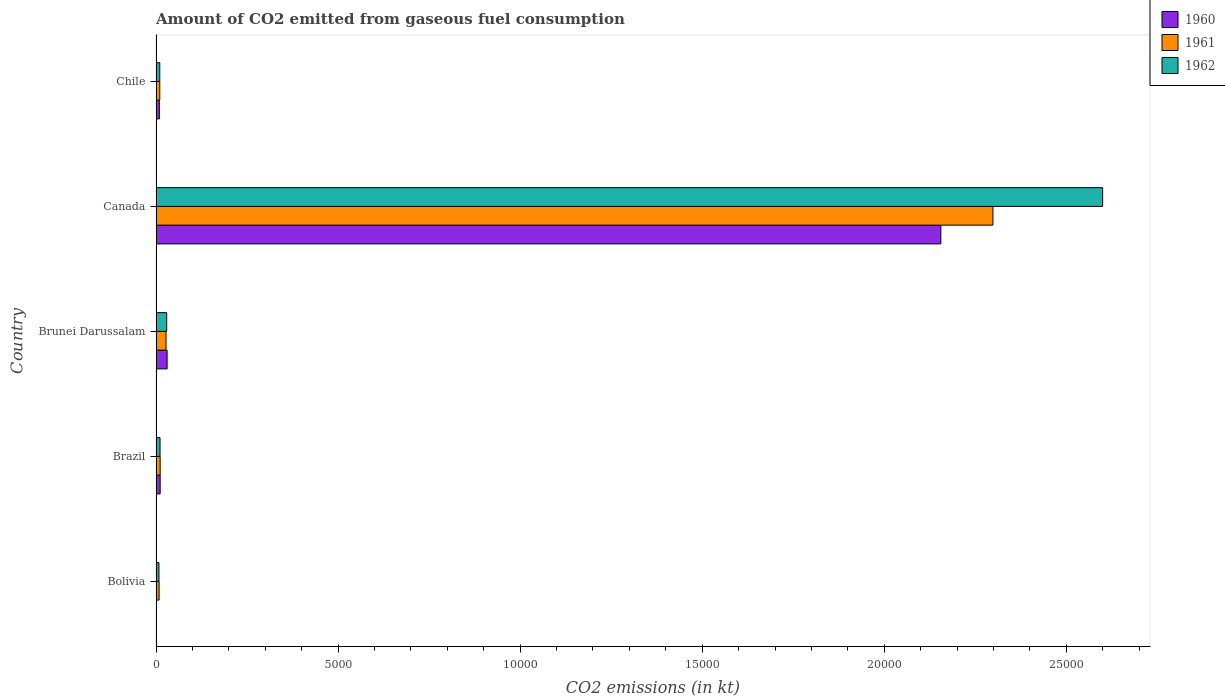Are the number of bars per tick equal to the number of legend labels?
Provide a short and direct response. Yes. Are the number of bars on each tick of the Y-axis equal?
Offer a very short reply. Yes. How many bars are there on the 2nd tick from the bottom?
Offer a terse response. 3. What is the label of the 1st group of bars from the top?
Your response must be concise. Chile. In how many cases, is the number of bars for a given country not equal to the number of legend labels?
Offer a terse response. 0. What is the amount of CO2 emitted in 1960 in Brazil?
Give a very brief answer. 113.68. Across all countries, what is the maximum amount of CO2 emitted in 1961?
Your response must be concise. 2.30e+04. Across all countries, what is the minimum amount of CO2 emitted in 1960?
Keep it short and to the point. 11. In which country was the amount of CO2 emitted in 1962 maximum?
Ensure brevity in your answer.  Canada. What is the total amount of CO2 emitted in 1961 in the graph?
Offer a terse response. 2.36e+04. What is the difference between the amount of CO2 emitted in 1962 in Bolivia and that in Chile?
Your answer should be compact. -22. What is the difference between the amount of CO2 emitted in 1960 in Canada and the amount of CO2 emitted in 1961 in Brazil?
Provide a succinct answer. 2.14e+04. What is the average amount of CO2 emitted in 1960 per country?
Your response must be concise. 4415.07. What is the difference between the amount of CO2 emitted in 1960 and amount of CO2 emitted in 1962 in Canada?
Give a very brief answer. -4444.4. What is the ratio of the amount of CO2 emitted in 1961 in Brunei Darussalam to that in Canada?
Your response must be concise. 0.01. Is the amount of CO2 emitted in 1962 in Brunei Darussalam less than that in Canada?
Provide a succinct answer. Yes. Is the difference between the amount of CO2 emitted in 1960 in Bolivia and Brunei Darussalam greater than the difference between the amount of CO2 emitted in 1962 in Bolivia and Brunei Darussalam?
Provide a short and direct response. No. What is the difference between the highest and the second highest amount of CO2 emitted in 1962?
Your response must be concise. 2.57e+04. What is the difference between the highest and the lowest amount of CO2 emitted in 1960?
Make the answer very short. 2.15e+04. What does the 3rd bar from the bottom in Brunei Darussalam represents?
Provide a short and direct response. 1962. Are all the bars in the graph horizontal?
Offer a terse response. Yes. How many countries are there in the graph?
Make the answer very short. 5. Where does the legend appear in the graph?
Your answer should be very brief. Top right. How many legend labels are there?
Your answer should be very brief. 3. How are the legend labels stacked?
Provide a short and direct response. Vertical. What is the title of the graph?
Your response must be concise. Amount of CO2 emitted from gaseous fuel consumption. What is the label or title of the X-axis?
Make the answer very short. CO2 emissions (in kt). What is the CO2 emissions (in kt) in 1960 in Bolivia?
Offer a very short reply. 11. What is the CO2 emissions (in kt) of 1961 in Bolivia?
Your response must be concise. 84.34. What is the CO2 emissions (in kt) of 1962 in Bolivia?
Ensure brevity in your answer.  80.67. What is the CO2 emissions (in kt) of 1960 in Brazil?
Your answer should be compact. 113.68. What is the CO2 emissions (in kt) of 1961 in Brazil?
Your response must be concise. 113.68. What is the CO2 emissions (in kt) of 1962 in Brazil?
Ensure brevity in your answer.  110.01. What is the CO2 emissions (in kt) in 1960 in Brunei Darussalam?
Offer a very short reply. 304.36. What is the CO2 emissions (in kt) of 1961 in Brunei Darussalam?
Provide a succinct answer. 275.02. What is the CO2 emissions (in kt) in 1962 in Brunei Darussalam?
Provide a short and direct response. 293.36. What is the CO2 emissions (in kt) in 1960 in Canada?
Your answer should be compact. 2.16e+04. What is the CO2 emissions (in kt) in 1961 in Canada?
Provide a succinct answer. 2.30e+04. What is the CO2 emissions (in kt) of 1962 in Canada?
Give a very brief answer. 2.60e+04. What is the CO2 emissions (in kt) in 1960 in Chile?
Your answer should be compact. 91.67. What is the CO2 emissions (in kt) in 1961 in Chile?
Give a very brief answer. 102.68. What is the CO2 emissions (in kt) of 1962 in Chile?
Make the answer very short. 102.68. Across all countries, what is the maximum CO2 emissions (in kt) in 1960?
Give a very brief answer. 2.16e+04. Across all countries, what is the maximum CO2 emissions (in kt) in 1961?
Offer a very short reply. 2.30e+04. Across all countries, what is the maximum CO2 emissions (in kt) in 1962?
Keep it short and to the point. 2.60e+04. Across all countries, what is the minimum CO2 emissions (in kt) in 1960?
Offer a very short reply. 11. Across all countries, what is the minimum CO2 emissions (in kt) in 1961?
Give a very brief answer. 84.34. Across all countries, what is the minimum CO2 emissions (in kt) of 1962?
Make the answer very short. 80.67. What is the total CO2 emissions (in kt) in 1960 in the graph?
Your answer should be compact. 2.21e+04. What is the total CO2 emissions (in kt) in 1961 in the graph?
Give a very brief answer. 2.36e+04. What is the total CO2 emissions (in kt) of 1962 in the graph?
Provide a short and direct response. 2.66e+04. What is the difference between the CO2 emissions (in kt) in 1960 in Bolivia and that in Brazil?
Keep it short and to the point. -102.68. What is the difference between the CO2 emissions (in kt) in 1961 in Bolivia and that in Brazil?
Ensure brevity in your answer.  -29.34. What is the difference between the CO2 emissions (in kt) in 1962 in Bolivia and that in Brazil?
Ensure brevity in your answer.  -29.34. What is the difference between the CO2 emissions (in kt) of 1960 in Bolivia and that in Brunei Darussalam?
Make the answer very short. -293.36. What is the difference between the CO2 emissions (in kt) of 1961 in Bolivia and that in Brunei Darussalam?
Make the answer very short. -190.68. What is the difference between the CO2 emissions (in kt) in 1962 in Bolivia and that in Brunei Darussalam?
Provide a short and direct response. -212.69. What is the difference between the CO2 emissions (in kt) of 1960 in Bolivia and that in Canada?
Offer a terse response. -2.15e+04. What is the difference between the CO2 emissions (in kt) of 1961 in Bolivia and that in Canada?
Make the answer very short. -2.29e+04. What is the difference between the CO2 emissions (in kt) in 1962 in Bolivia and that in Canada?
Your answer should be compact. -2.59e+04. What is the difference between the CO2 emissions (in kt) in 1960 in Bolivia and that in Chile?
Your response must be concise. -80.67. What is the difference between the CO2 emissions (in kt) in 1961 in Bolivia and that in Chile?
Keep it short and to the point. -18.34. What is the difference between the CO2 emissions (in kt) of 1962 in Bolivia and that in Chile?
Your answer should be compact. -22. What is the difference between the CO2 emissions (in kt) in 1960 in Brazil and that in Brunei Darussalam?
Provide a short and direct response. -190.68. What is the difference between the CO2 emissions (in kt) in 1961 in Brazil and that in Brunei Darussalam?
Offer a very short reply. -161.35. What is the difference between the CO2 emissions (in kt) of 1962 in Brazil and that in Brunei Darussalam?
Offer a terse response. -183.35. What is the difference between the CO2 emissions (in kt) in 1960 in Brazil and that in Canada?
Provide a short and direct response. -2.14e+04. What is the difference between the CO2 emissions (in kt) of 1961 in Brazil and that in Canada?
Keep it short and to the point. -2.29e+04. What is the difference between the CO2 emissions (in kt) of 1962 in Brazil and that in Canada?
Give a very brief answer. -2.59e+04. What is the difference between the CO2 emissions (in kt) of 1960 in Brazil and that in Chile?
Provide a short and direct response. 22. What is the difference between the CO2 emissions (in kt) of 1961 in Brazil and that in Chile?
Make the answer very short. 11. What is the difference between the CO2 emissions (in kt) of 1962 in Brazil and that in Chile?
Ensure brevity in your answer.  7.33. What is the difference between the CO2 emissions (in kt) in 1960 in Brunei Darussalam and that in Canada?
Offer a very short reply. -2.13e+04. What is the difference between the CO2 emissions (in kt) in 1961 in Brunei Darussalam and that in Canada?
Provide a succinct answer. -2.27e+04. What is the difference between the CO2 emissions (in kt) in 1962 in Brunei Darussalam and that in Canada?
Provide a succinct answer. -2.57e+04. What is the difference between the CO2 emissions (in kt) in 1960 in Brunei Darussalam and that in Chile?
Keep it short and to the point. 212.69. What is the difference between the CO2 emissions (in kt) in 1961 in Brunei Darussalam and that in Chile?
Make the answer very short. 172.35. What is the difference between the CO2 emissions (in kt) of 1962 in Brunei Darussalam and that in Chile?
Provide a short and direct response. 190.68. What is the difference between the CO2 emissions (in kt) of 1960 in Canada and that in Chile?
Your answer should be very brief. 2.15e+04. What is the difference between the CO2 emissions (in kt) in 1961 in Canada and that in Chile?
Give a very brief answer. 2.29e+04. What is the difference between the CO2 emissions (in kt) in 1962 in Canada and that in Chile?
Provide a succinct answer. 2.59e+04. What is the difference between the CO2 emissions (in kt) in 1960 in Bolivia and the CO2 emissions (in kt) in 1961 in Brazil?
Your response must be concise. -102.68. What is the difference between the CO2 emissions (in kt) of 1960 in Bolivia and the CO2 emissions (in kt) of 1962 in Brazil?
Your answer should be very brief. -99.01. What is the difference between the CO2 emissions (in kt) of 1961 in Bolivia and the CO2 emissions (in kt) of 1962 in Brazil?
Your answer should be very brief. -25.67. What is the difference between the CO2 emissions (in kt) in 1960 in Bolivia and the CO2 emissions (in kt) in 1961 in Brunei Darussalam?
Provide a short and direct response. -264.02. What is the difference between the CO2 emissions (in kt) of 1960 in Bolivia and the CO2 emissions (in kt) of 1962 in Brunei Darussalam?
Your answer should be very brief. -282.36. What is the difference between the CO2 emissions (in kt) of 1961 in Bolivia and the CO2 emissions (in kt) of 1962 in Brunei Darussalam?
Offer a terse response. -209.02. What is the difference between the CO2 emissions (in kt) in 1960 in Bolivia and the CO2 emissions (in kt) in 1961 in Canada?
Your answer should be very brief. -2.30e+04. What is the difference between the CO2 emissions (in kt) of 1960 in Bolivia and the CO2 emissions (in kt) of 1962 in Canada?
Keep it short and to the point. -2.60e+04. What is the difference between the CO2 emissions (in kt) of 1961 in Bolivia and the CO2 emissions (in kt) of 1962 in Canada?
Ensure brevity in your answer.  -2.59e+04. What is the difference between the CO2 emissions (in kt) of 1960 in Bolivia and the CO2 emissions (in kt) of 1961 in Chile?
Make the answer very short. -91.67. What is the difference between the CO2 emissions (in kt) in 1960 in Bolivia and the CO2 emissions (in kt) in 1962 in Chile?
Offer a very short reply. -91.67. What is the difference between the CO2 emissions (in kt) of 1961 in Bolivia and the CO2 emissions (in kt) of 1962 in Chile?
Ensure brevity in your answer.  -18.34. What is the difference between the CO2 emissions (in kt) in 1960 in Brazil and the CO2 emissions (in kt) in 1961 in Brunei Darussalam?
Make the answer very short. -161.35. What is the difference between the CO2 emissions (in kt) of 1960 in Brazil and the CO2 emissions (in kt) of 1962 in Brunei Darussalam?
Make the answer very short. -179.68. What is the difference between the CO2 emissions (in kt) in 1961 in Brazil and the CO2 emissions (in kt) in 1962 in Brunei Darussalam?
Offer a very short reply. -179.68. What is the difference between the CO2 emissions (in kt) of 1960 in Brazil and the CO2 emissions (in kt) of 1961 in Canada?
Keep it short and to the point. -2.29e+04. What is the difference between the CO2 emissions (in kt) of 1960 in Brazil and the CO2 emissions (in kt) of 1962 in Canada?
Keep it short and to the point. -2.59e+04. What is the difference between the CO2 emissions (in kt) of 1961 in Brazil and the CO2 emissions (in kt) of 1962 in Canada?
Make the answer very short. -2.59e+04. What is the difference between the CO2 emissions (in kt) in 1960 in Brazil and the CO2 emissions (in kt) in 1961 in Chile?
Offer a very short reply. 11. What is the difference between the CO2 emissions (in kt) in 1960 in Brazil and the CO2 emissions (in kt) in 1962 in Chile?
Provide a succinct answer. 11. What is the difference between the CO2 emissions (in kt) in 1961 in Brazil and the CO2 emissions (in kt) in 1962 in Chile?
Ensure brevity in your answer.  11. What is the difference between the CO2 emissions (in kt) in 1960 in Brunei Darussalam and the CO2 emissions (in kt) in 1961 in Canada?
Offer a terse response. -2.27e+04. What is the difference between the CO2 emissions (in kt) in 1960 in Brunei Darussalam and the CO2 emissions (in kt) in 1962 in Canada?
Provide a short and direct response. -2.57e+04. What is the difference between the CO2 emissions (in kt) in 1961 in Brunei Darussalam and the CO2 emissions (in kt) in 1962 in Canada?
Make the answer very short. -2.57e+04. What is the difference between the CO2 emissions (in kt) in 1960 in Brunei Darussalam and the CO2 emissions (in kt) in 1961 in Chile?
Your answer should be compact. 201.69. What is the difference between the CO2 emissions (in kt) of 1960 in Brunei Darussalam and the CO2 emissions (in kt) of 1962 in Chile?
Offer a terse response. 201.69. What is the difference between the CO2 emissions (in kt) in 1961 in Brunei Darussalam and the CO2 emissions (in kt) in 1962 in Chile?
Provide a short and direct response. 172.35. What is the difference between the CO2 emissions (in kt) of 1960 in Canada and the CO2 emissions (in kt) of 1961 in Chile?
Give a very brief answer. 2.15e+04. What is the difference between the CO2 emissions (in kt) of 1960 in Canada and the CO2 emissions (in kt) of 1962 in Chile?
Your response must be concise. 2.15e+04. What is the difference between the CO2 emissions (in kt) of 1961 in Canada and the CO2 emissions (in kt) of 1962 in Chile?
Provide a succinct answer. 2.29e+04. What is the average CO2 emissions (in kt) of 1960 per country?
Provide a short and direct response. 4415.07. What is the average CO2 emissions (in kt) of 1961 per country?
Provide a succinct answer. 4712.1. What is the average CO2 emissions (in kt) in 1962 per country?
Give a very brief answer. 5317.15. What is the difference between the CO2 emissions (in kt) in 1960 and CO2 emissions (in kt) in 1961 in Bolivia?
Make the answer very short. -73.34. What is the difference between the CO2 emissions (in kt) of 1960 and CO2 emissions (in kt) of 1962 in Bolivia?
Give a very brief answer. -69.67. What is the difference between the CO2 emissions (in kt) in 1961 and CO2 emissions (in kt) in 1962 in Bolivia?
Make the answer very short. 3.67. What is the difference between the CO2 emissions (in kt) of 1960 and CO2 emissions (in kt) of 1962 in Brazil?
Provide a succinct answer. 3.67. What is the difference between the CO2 emissions (in kt) of 1961 and CO2 emissions (in kt) of 1962 in Brazil?
Provide a short and direct response. 3.67. What is the difference between the CO2 emissions (in kt) of 1960 and CO2 emissions (in kt) of 1961 in Brunei Darussalam?
Keep it short and to the point. 29.34. What is the difference between the CO2 emissions (in kt) of 1960 and CO2 emissions (in kt) of 1962 in Brunei Darussalam?
Keep it short and to the point. 11. What is the difference between the CO2 emissions (in kt) of 1961 and CO2 emissions (in kt) of 1962 in Brunei Darussalam?
Make the answer very short. -18.34. What is the difference between the CO2 emissions (in kt) in 1960 and CO2 emissions (in kt) in 1961 in Canada?
Provide a short and direct response. -1430.13. What is the difference between the CO2 emissions (in kt) of 1960 and CO2 emissions (in kt) of 1962 in Canada?
Your answer should be compact. -4444.4. What is the difference between the CO2 emissions (in kt) in 1961 and CO2 emissions (in kt) in 1962 in Canada?
Offer a terse response. -3014.27. What is the difference between the CO2 emissions (in kt) of 1960 and CO2 emissions (in kt) of 1961 in Chile?
Make the answer very short. -11. What is the difference between the CO2 emissions (in kt) in 1960 and CO2 emissions (in kt) in 1962 in Chile?
Give a very brief answer. -11. What is the difference between the CO2 emissions (in kt) in 1961 and CO2 emissions (in kt) in 1962 in Chile?
Give a very brief answer. 0. What is the ratio of the CO2 emissions (in kt) of 1960 in Bolivia to that in Brazil?
Make the answer very short. 0.1. What is the ratio of the CO2 emissions (in kt) in 1961 in Bolivia to that in Brazil?
Your answer should be very brief. 0.74. What is the ratio of the CO2 emissions (in kt) in 1962 in Bolivia to that in Brazil?
Offer a terse response. 0.73. What is the ratio of the CO2 emissions (in kt) in 1960 in Bolivia to that in Brunei Darussalam?
Make the answer very short. 0.04. What is the ratio of the CO2 emissions (in kt) of 1961 in Bolivia to that in Brunei Darussalam?
Provide a short and direct response. 0.31. What is the ratio of the CO2 emissions (in kt) in 1962 in Bolivia to that in Brunei Darussalam?
Provide a short and direct response. 0.28. What is the ratio of the CO2 emissions (in kt) in 1961 in Bolivia to that in Canada?
Provide a short and direct response. 0. What is the ratio of the CO2 emissions (in kt) of 1962 in Bolivia to that in Canada?
Ensure brevity in your answer.  0. What is the ratio of the CO2 emissions (in kt) in 1960 in Bolivia to that in Chile?
Your answer should be very brief. 0.12. What is the ratio of the CO2 emissions (in kt) in 1961 in Bolivia to that in Chile?
Offer a terse response. 0.82. What is the ratio of the CO2 emissions (in kt) in 1962 in Bolivia to that in Chile?
Your response must be concise. 0.79. What is the ratio of the CO2 emissions (in kt) in 1960 in Brazil to that in Brunei Darussalam?
Provide a short and direct response. 0.37. What is the ratio of the CO2 emissions (in kt) in 1961 in Brazil to that in Brunei Darussalam?
Provide a succinct answer. 0.41. What is the ratio of the CO2 emissions (in kt) of 1960 in Brazil to that in Canada?
Make the answer very short. 0.01. What is the ratio of the CO2 emissions (in kt) of 1961 in Brazil to that in Canada?
Offer a very short reply. 0. What is the ratio of the CO2 emissions (in kt) of 1962 in Brazil to that in Canada?
Keep it short and to the point. 0. What is the ratio of the CO2 emissions (in kt) of 1960 in Brazil to that in Chile?
Your response must be concise. 1.24. What is the ratio of the CO2 emissions (in kt) in 1961 in Brazil to that in Chile?
Give a very brief answer. 1.11. What is the ratio of the CO2 emissions (in kt) in 1962 in Brazil to that in Chile?
Ensure brevity in your answer.  1.07. What is the ratio of the CO2 emissions (in kt) in 1960 in Brunei Darussalam to that in Canada?
Make the answer very short. 0.01. What is the ratio of the CO2 emissions (in kt) of 1961 in Brunei Darussalam to that in Canada?
Offer a very short reply. 0.01. What is the ratio of the CO2 emissions (in kt) in 1962 in Brunei Darussalam to that in Canada?
Make the answer very short. 0.01. What is the ratio of the CO2 emissions (in kt) of 1960 in Brunei Darussalam to that in Chile?
Your answer should be compact. 3.32. What is the ratio of the CO2 emissions (in kt) in 1961 in Brunei Darussalam to that in Chile?
Keep it short and to the point. 2.68. What is the ratio of the CO2 emissions (in kt) of 1962 in Brunei Darussalam to that in Chile?
Your answer should be very brief. 2.86. What is the ratio of the CO2 emissions (in kt) in 1960 in Canada to that in Chile?
Ensure brevity in your answer.  235.12. What is the ratio of the CO2 emissions (in kt) in 1961 in Canada to that in Chile?
Keep it short and to the point. 223.86. What is the ratio of the CO2 emissions (in kt) in 1962 in Canada to that in Chile?
Offer a terse response. 253.21. What is the difference between the highest and the second highest CO2 emissions (in kt) in 1960?
Provide a succinct answer. 2.13e+04. What is the difference between the highest and the second highest CO2 emissions (in kt) of 1961?
Your answer should be compact. 2.27e+04. What is the difference between the highest and the second highest CO2 emissions (in kt) in 1962?
Your answer should be very brief. 2.57e+04. What is the difference between the highest and the lowest CO2 emissions (in kt) in 1960?
Your response must be concise. 2.15e+04. What is the difference between the highest and the lowest CO2 emissions (in kt) in 1961?
Ensure brevity in your answer.  2.29e+04. What is the difference between the highest and the lowest CO2 emissions (in kt) of 1962?
Ensure brevity in your answer.  2.59e+04. 